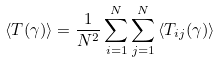<formula> <loc_0><loc_0><loc_500><loc_500>\langle T ( \gamma ) \rangle = \frac { 1 } { N ^ { 2 } } \sum _ { i = 1 } ^ { N } \sum _ { j = 1 } ^ { N } \left \langle T _ { i j } ( \gamma ) \right \rangle</formula> 